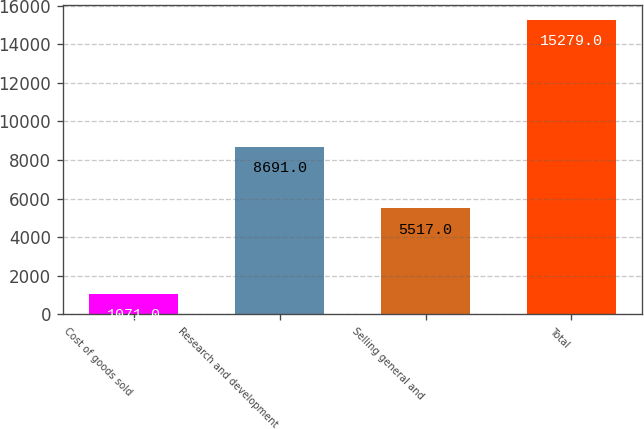<chart> <loc_0><loc_0><loc_500><loc_500><bar_chart><fcel>Cost of goods sold<fcel>Research and development<fcel>Selling general and<fcel>Total<nl><fcel>1071<fcel>8691<fcel>5517<fcel>15279<nl></chart> 